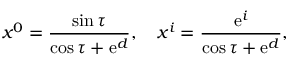<formula> <loc_0><loc_0><loc_500><loc_500>x ^ { 0 } = \frac { \sin \tau } { \cos \tau + e ^ { d } } , \quad x ^ { i } = \frac { e ^ { i } } { \cos \tau + e ^ { d } } ,</formula> 